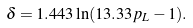<formula> <loc_0><loc_0><loc_500><loc_500>\delta = 1 . 4 4 3 \ln ( 1 3 . 3 3 p _ { L } - 1 ) .</formula> 